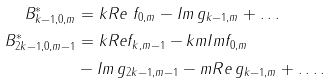Convert formula to latex. <formula><loc_0><loc_0><loc_500><loc_500>B ^ { * } _ { k - 1 , 0 , m } & = k R e \ f _ { 0 , m } - I m \, g _ { k - 1 , m } + \dots \\ B ^ { * } _ { 2 k - 1 , 0 , m - 1 } & = k R e f _ { k , m - 1 } - k m I m f _ { 0 , m } \\ & - I m \, g _ { 2 k - 1 , m - 1 } - m R e \, g _ { k - 1 , m } + \dots .</formula> 